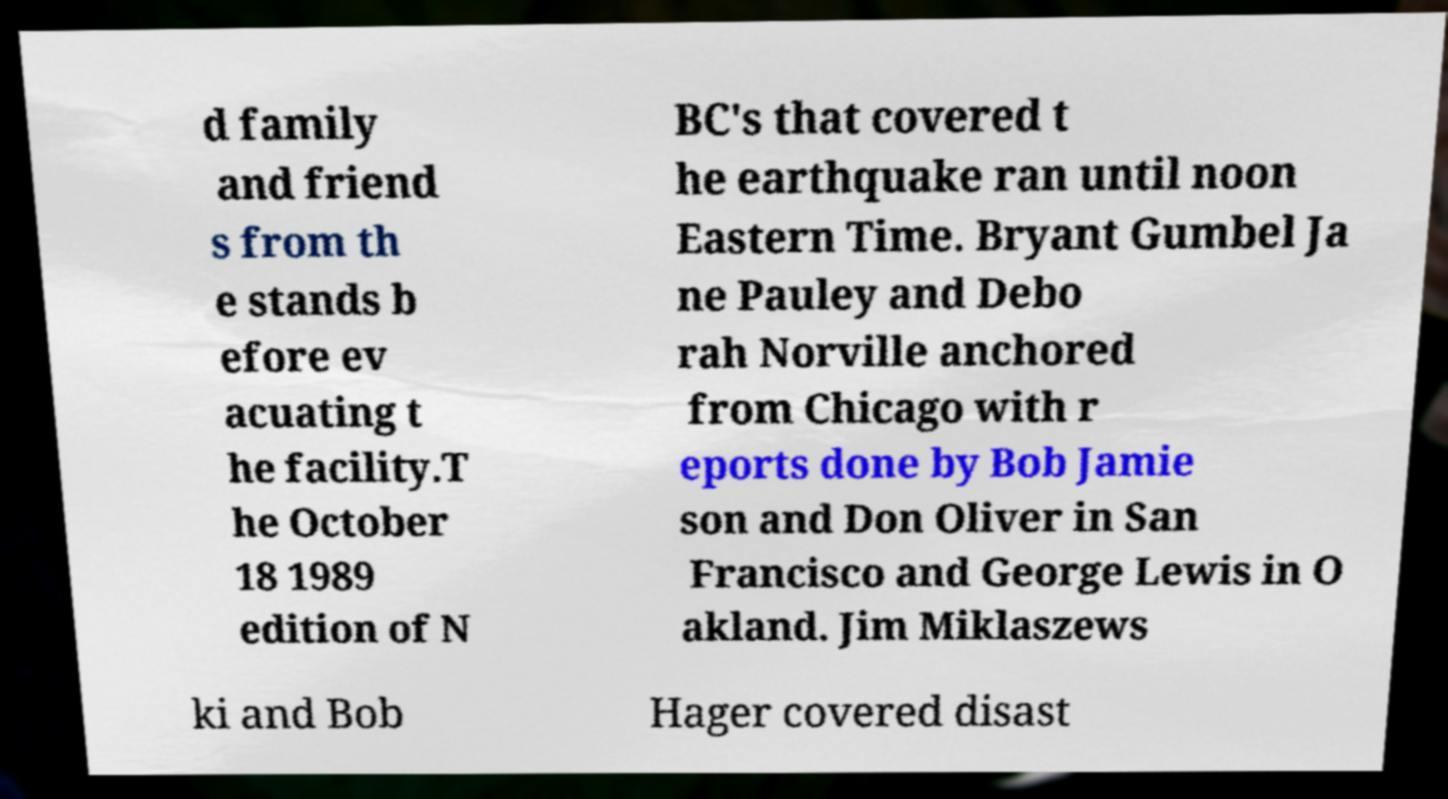For documentation purposes, I need the text within this image transcribed. Could you provide that? d family and friend s from th e stands b efore ev acuating t he facility.T he October 18 1989 edition of N BC's that covered t he earthquake ran until noon Eastern Time. Bryant Gumbel Ja ne Pauley and Debo rah Norville anchored from Chicago with r eports done by Bob Jamie son and Don Oliver in San Francisco and George Lewis in O akland. Jim Miklaszews ki and Bob Hager covered disast 